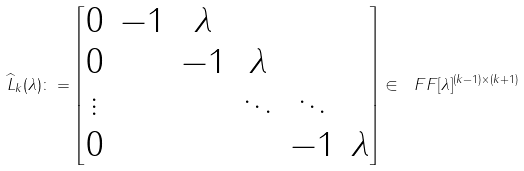<formula> <loc_0><loc_0><loc_500><loc_500>\widehat { L } _ { k } ( \lambda ) \colon = \begin{bmatrix} 0 & - 1 & \lambda \\ 0 & & - 1 & \lambda \\ \vdots & & & \ddots & \ddots \\ 0 & & & & - 1 & \lambda \end{bmatrix} \in \ F F [ \lambda ] ^ { ( k - 1 ) \times ( k + 1 ) }</formula> 